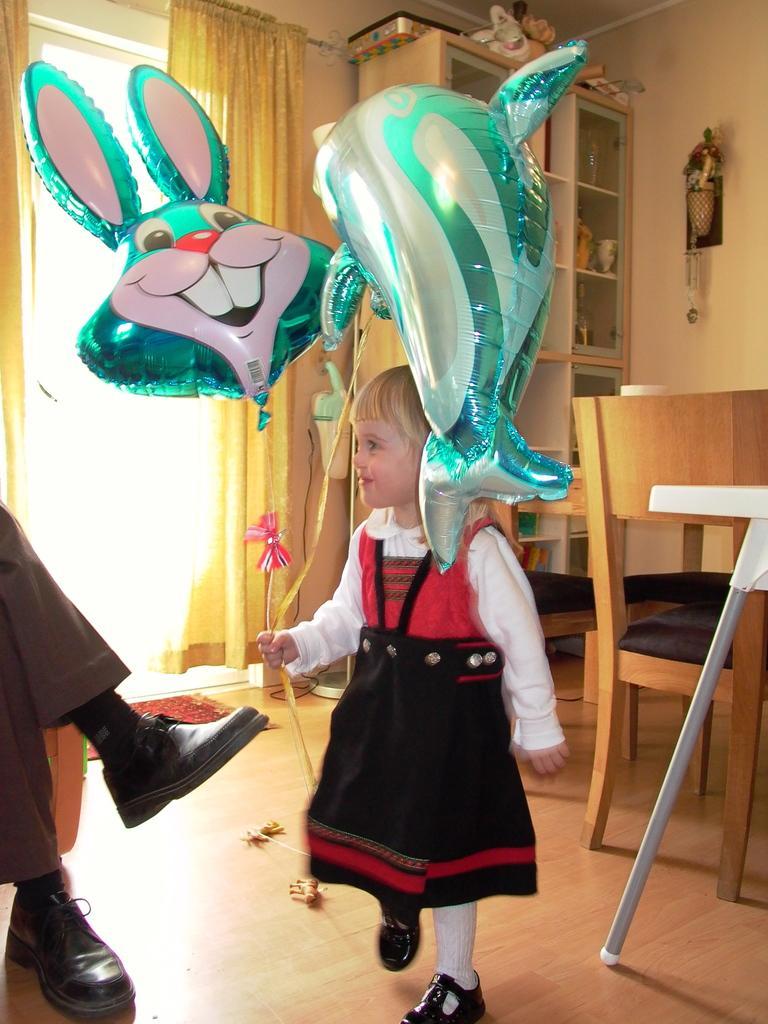Please provide a concise description of this image. This picture is clicked inside the house, where a girl is standing in the middle. At the right side there is the chair and table, cupboard. In the center there is a curtain to the window. Left side the legs of a person with shoes which black in colour is visible. 